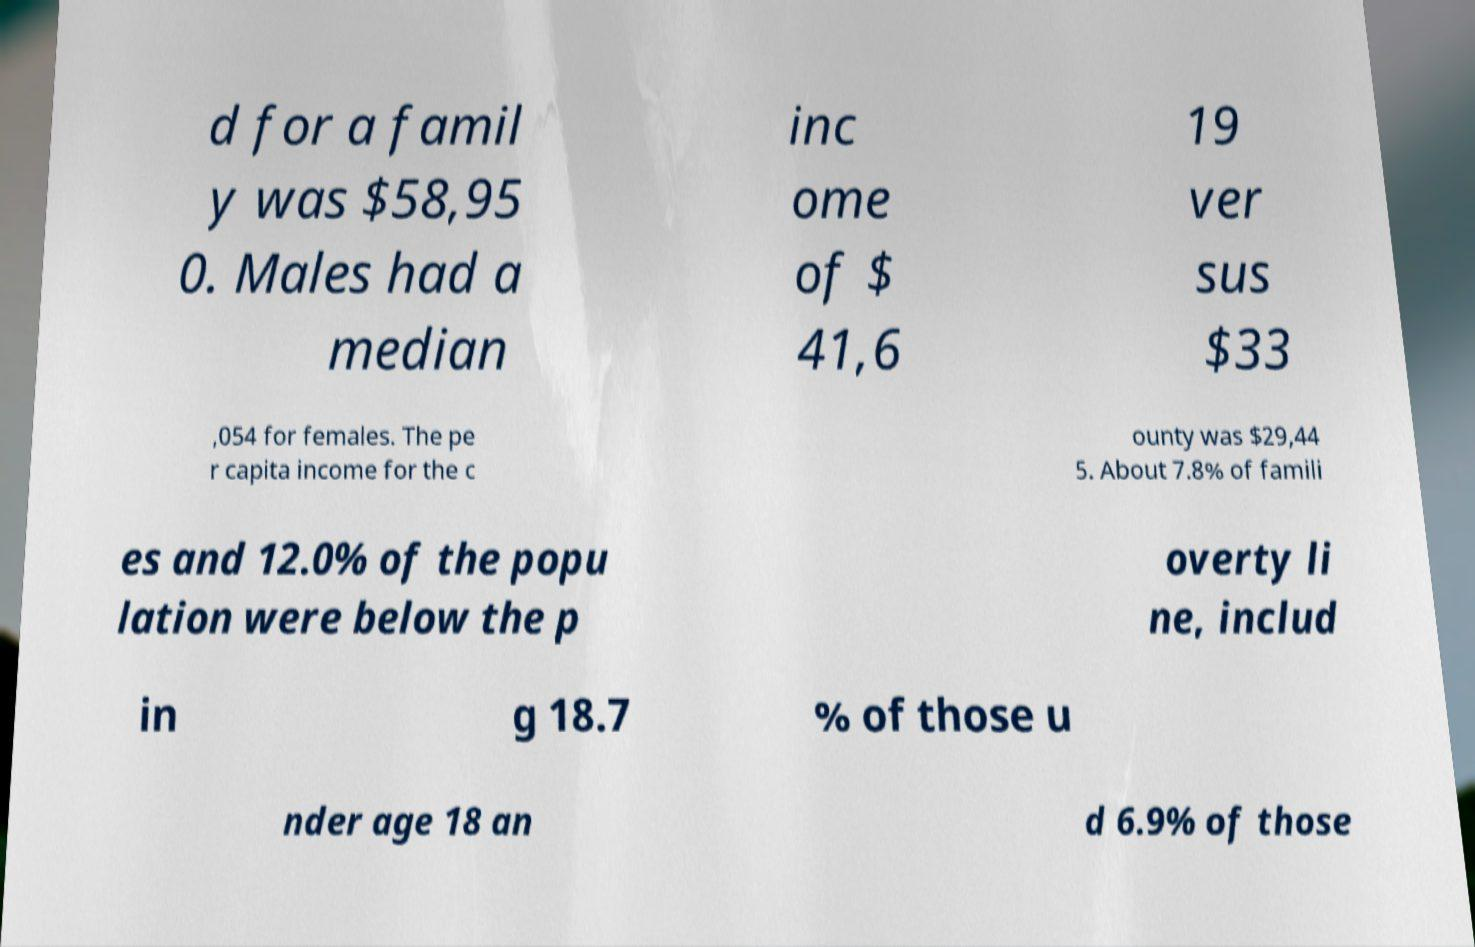Please identify and transcribe the text found in this image. d for a famil y was $58,95 0. Males had a median inc ome of $ 41,6 19 ver sus $33 ,054 for females. The pe r capita income for the c ounty was $29,44 5. About 7.8% of famili es and 12.0% of the popu lation were below the p overty li ne, includ in g 18.7 % of those u nder age 18 an d 6.9% of those 